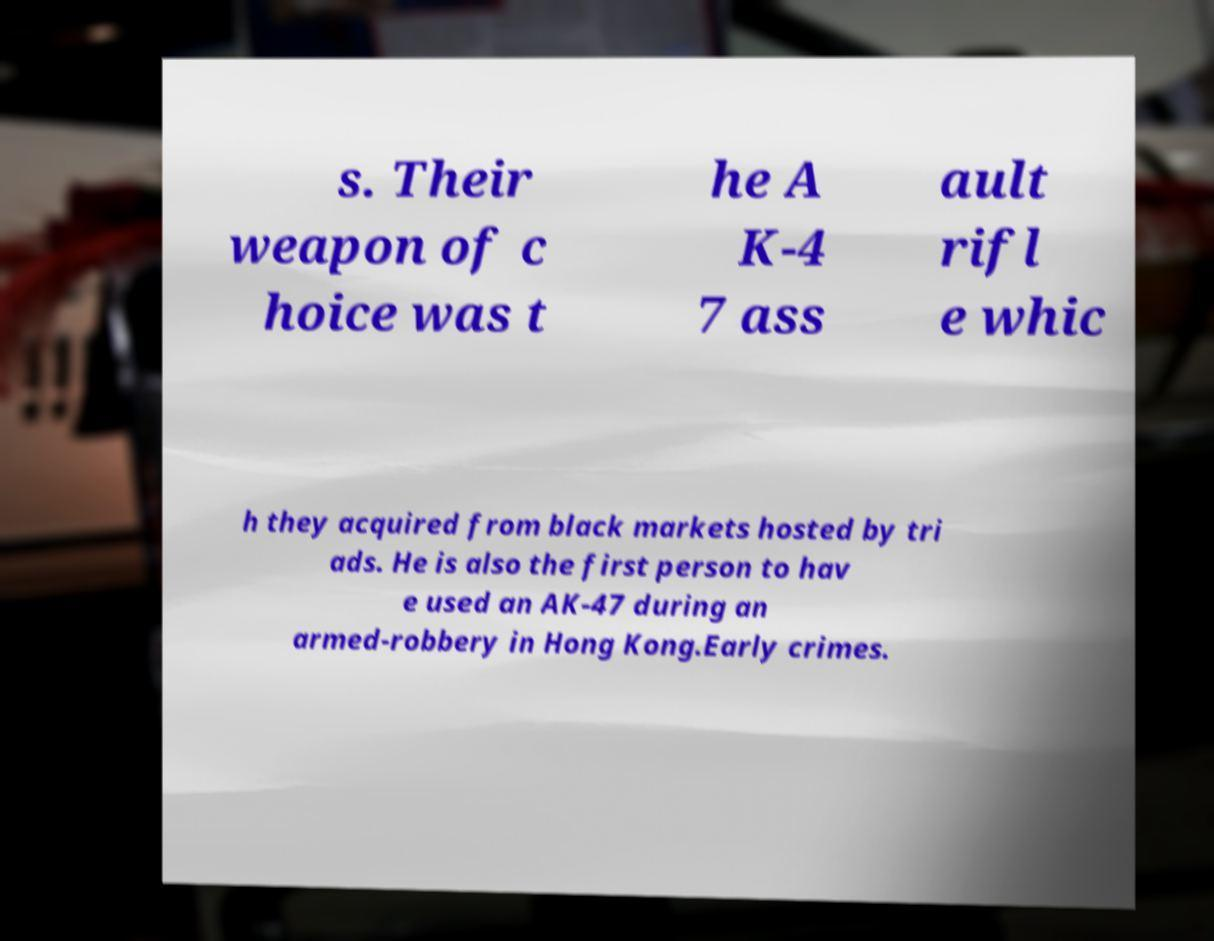For documentation purposes, I need the text within this image transcribed. Could you provide that? s. Their weapon of c hoice was t he A K-4 7 ass ault rifl e whic h they acquired from black markets hosted by tri ads. He is also the first person to hav e used an AK-47 during an armed-robbery in Hong Kong.Early crimes. 